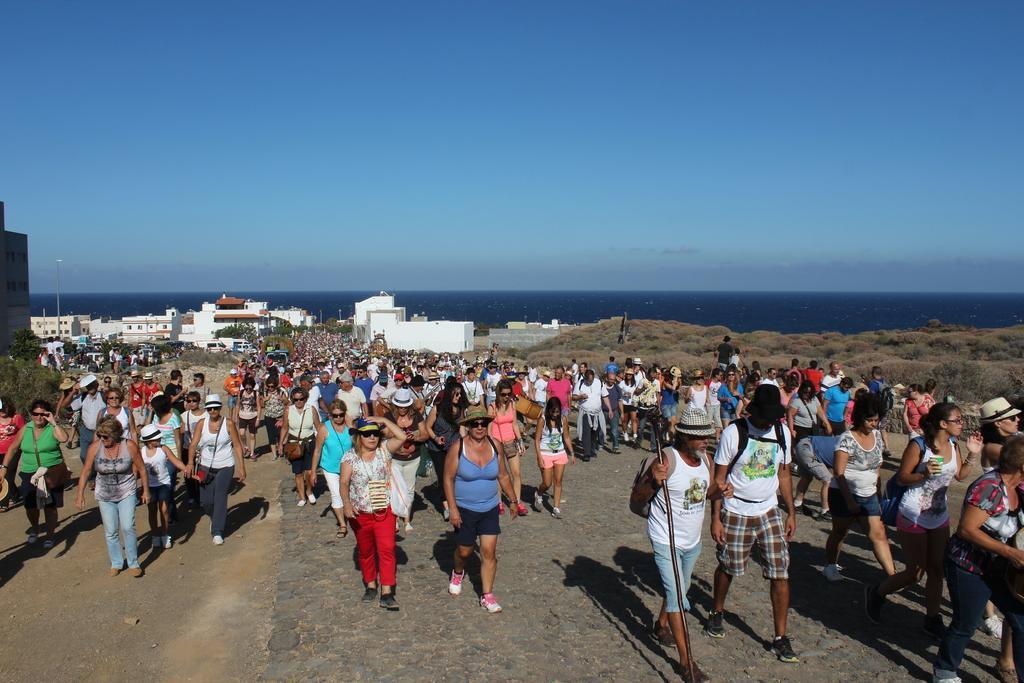Describe this image in one or two sentences. In this image we can see many persons walking on the road. In the background we can see trees, buildings, plants, grass, water, poles, sky and clouds. 